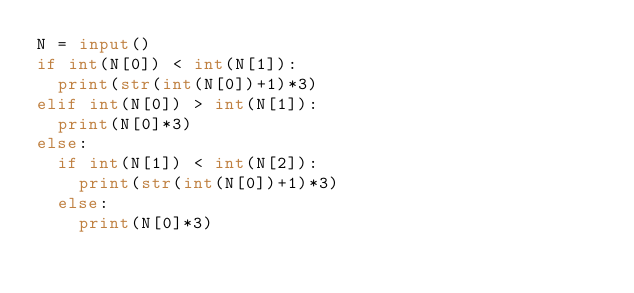<code> <loc_0><loc_0><loc_500><loc_500><_Python_>N = input()
if int(N[0]) < int(N[1]):
  print(str(int(N[0])+1)*3)
elif int(N[0]) > int(N[1]):
  print(N[0]*3)
else:
  if int(N[1]) < int(N[2]):
    print(str(int(N[0])+1)*3)
  else:
    print(N[0]*3)</code> 